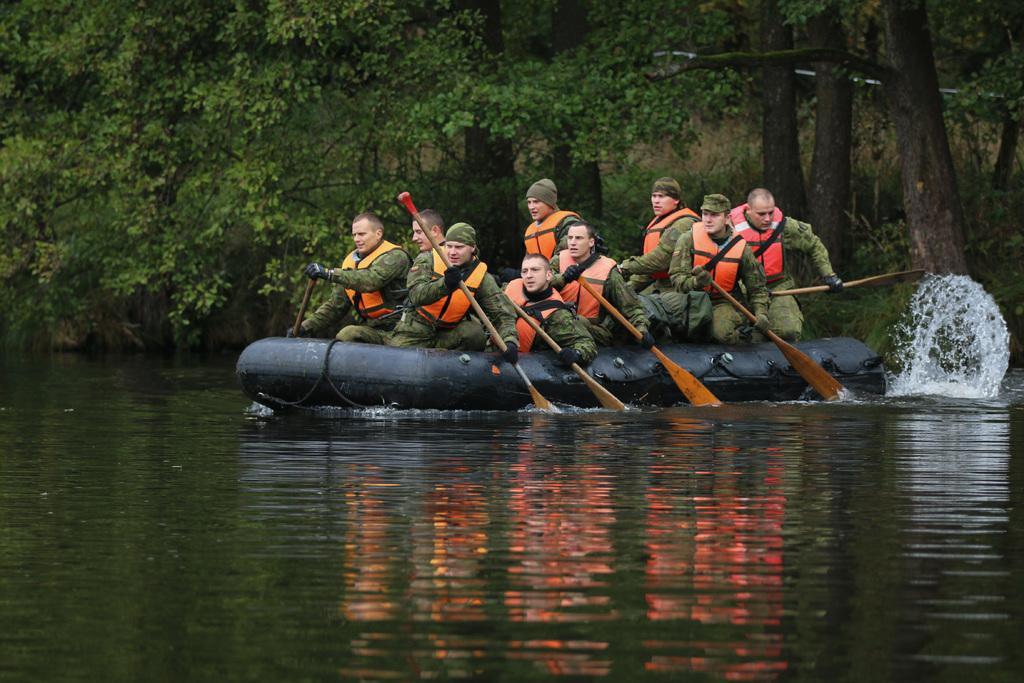In one or two sentences, can you explain what this image depicts? In this picture I can see there are a few people sitting in a raft and they are holding wooden sticks and the people in the raft are wearing life jackets. In the backdrop, there are trees and plants. 